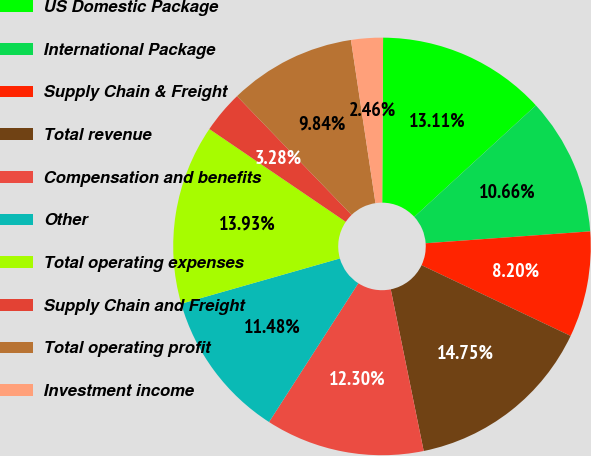<chart> <loc_0><loc_0><loc_500><loc_500><pie_chart><fcel>US Domestic Package<fcel>International Package<fcel>Supply Chain & Freight<fcel>Total revenue<fcel>Compensation and benefits<fcel>Other<fcel>Total operating expenses<fcel>Supply Chain and Freight<fcel>Total operating profit<fcel>Investment income<nl><fcel>13.11%<fcel>10.66%<fcel>8.2%<fcel>14.75%<fcel>12.3%<fcel>11.48%<fcel>13.93%<fcel>3.28%<fcel>9.84%<fcel>2.46%<nl></chart> 